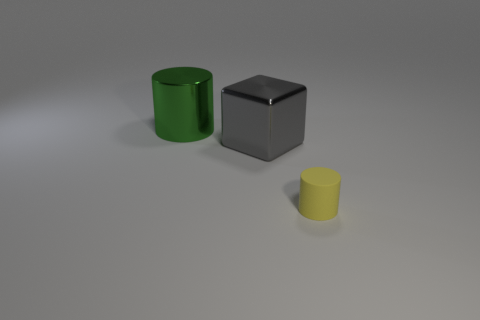Add 2 rubber cylinders. How many objects exist? 5 Subtract all cylinders. How many objects are left? 1 Add 2 yellow things. How many yellow things are left? 3 Add 3 big matte blocks. How many big matte blocks exist? 3 Subtract 0 blue spheres. How many objects are left? 3 Subtract all gray rubber blocks. Subtract all large green metallic things. How many objects are left? 2 